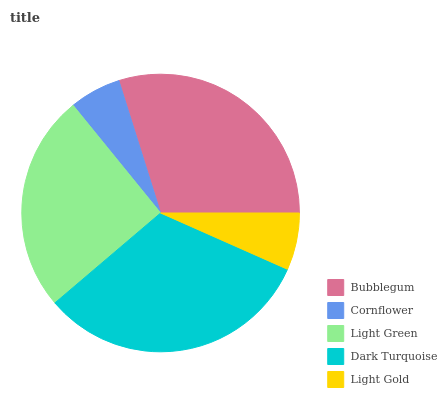Is Cornflower the minimum?
Answer yes or no. Yes. Is Dark Turquoise the maximum?
Answer yes or no. Yes. Is Light Green the minimum?
Answer yes or no. No. Is Light Green the maximum?
Answer yes or no. No. Is Light Green greater than Cornflower?
Answer yes or no. Yes. Is Cornflower less than Light Green?
Answer yes or no. Yes. Is Cornflower greater than Light Green?
Answer yes or no. No. Is Light Green less than Cornflower?
Answer yes or no. No. Is Light Green the high median?
Answer yes or no. Yes. Is Light Green the low median?
Answer yes or no. Yes. Is Bubblegum the high median?
Answer yes or no. No. Is Dark Turquoise the low median?
Answer yes or no. No. 